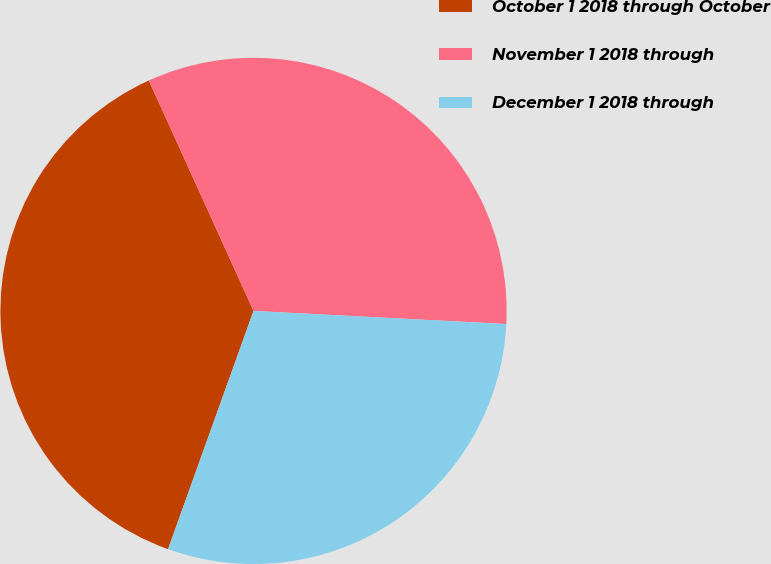Convert chart to OTSL. <chart><loc_0><loc_0><loc_500><loc_500><pie_chart><fcel>October 1 2018 through October<fcel>November 1 2018 through<fcel>December 1 2018 through<nl><fcel>37.73%<fcel>32.61%<fcel>29.66%<nl></chart> 